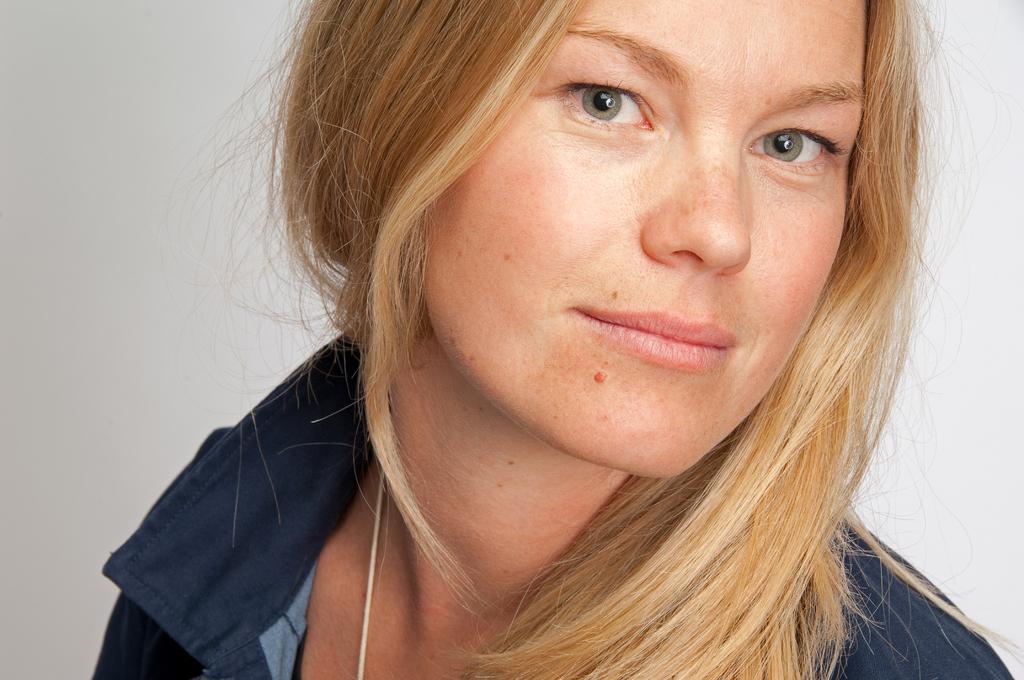Can you describe this image briefly? In this image there is a woman wearing a shirt. Background there is a wall. 